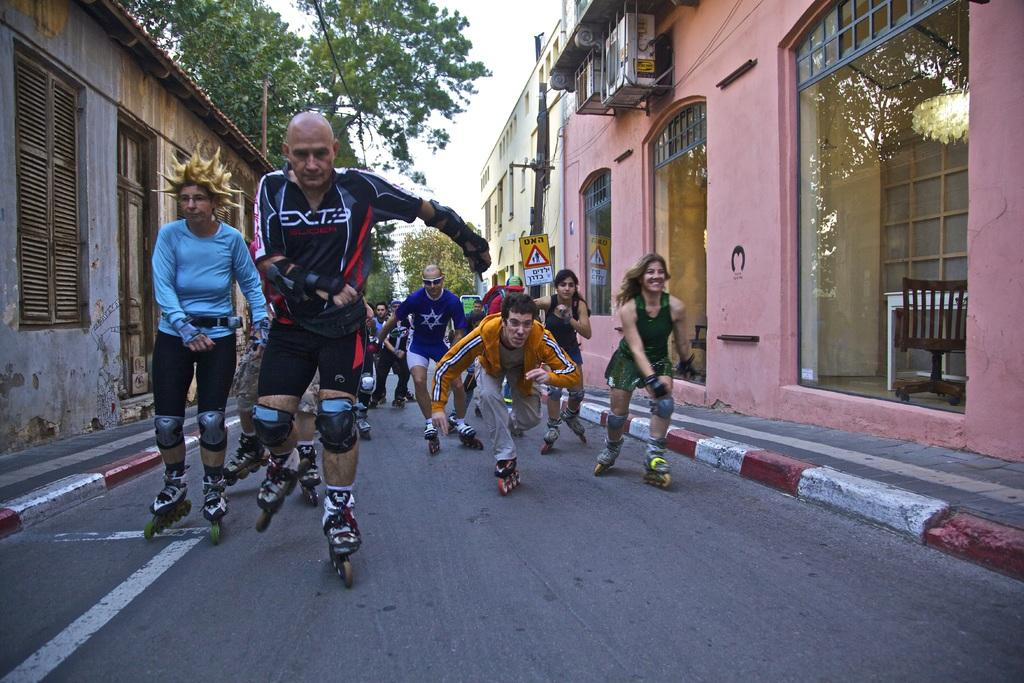How many people are in the image? There is a group of persons in the image. What are the persons doing in the image? The persons are skating on the road. What can be seen in the background of the image? There are trees and buildings in the background of the image. What is the color of the persons' tongues in the image? There is no information about the color of the persons' tongues in the image. What beliefs do the persons in the image hold? There is no information about the beliefs of the persons in the image. 